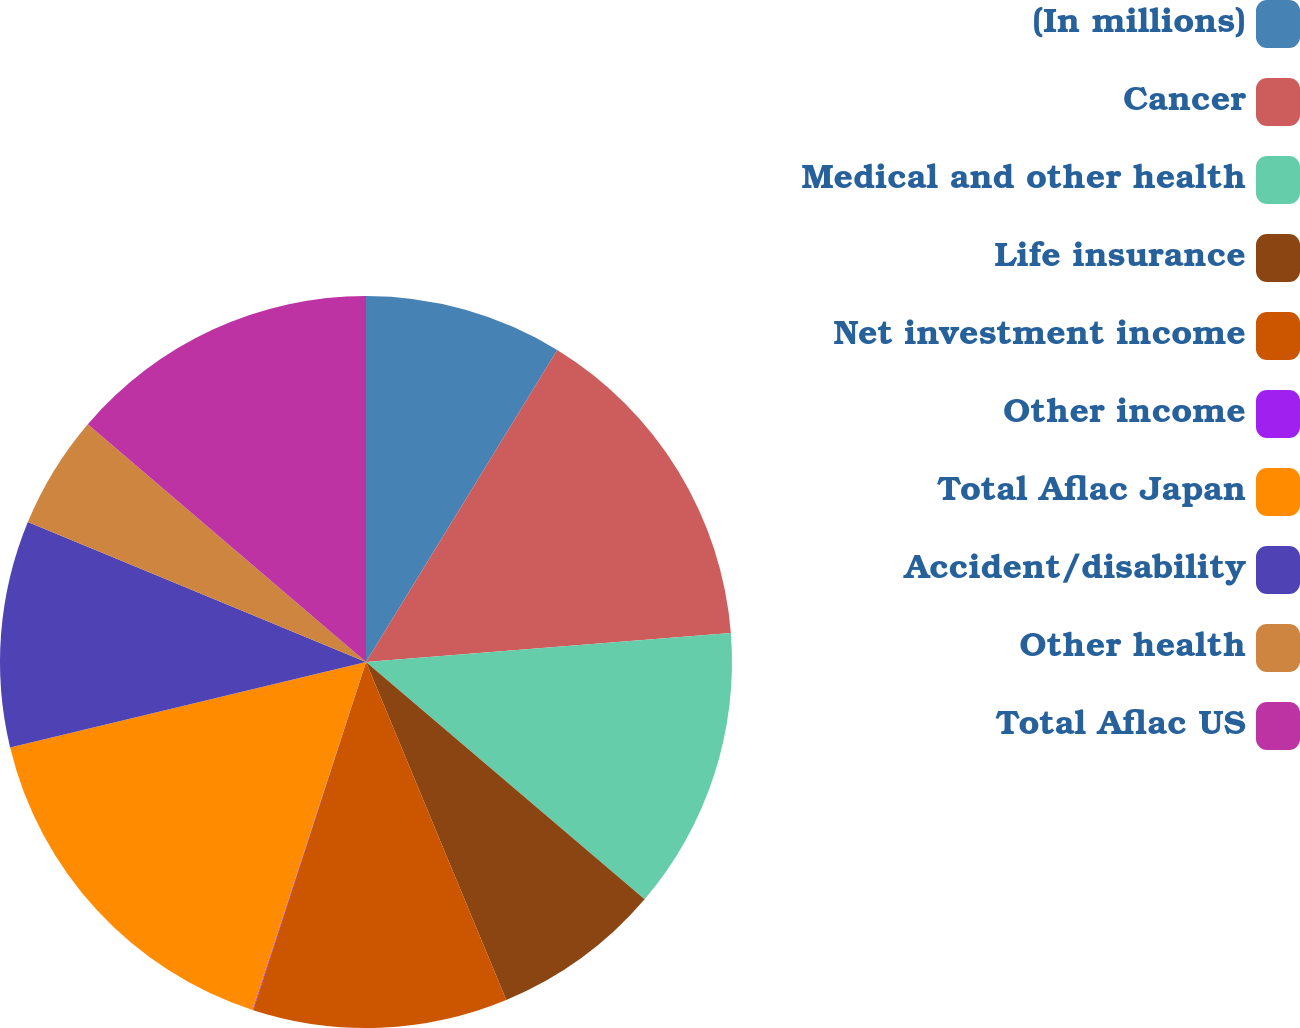Convert chart to OTSL. <chart><loc_0><loc_0><loc_500><loc_500><pie_chart><fcel>(In millions)<fcel>Cancer<fcel>Medical and other health<fcel>Life insurance<fcel>Net investment income<fcel>Other income<fcel>Total Aflac Japan<fcel>Accident/disability<fcel>Other health<fcel>Total Aflac US<nl><fcel>8.75%<fcel>14.99%<fcel>12.49%<fcel>7.51%<fcel>11.25%<fcel>0.03%<fcel>16.23%<fcel>10.0%<fcel>5.01%<fcel>13.74%<nl></chart> 